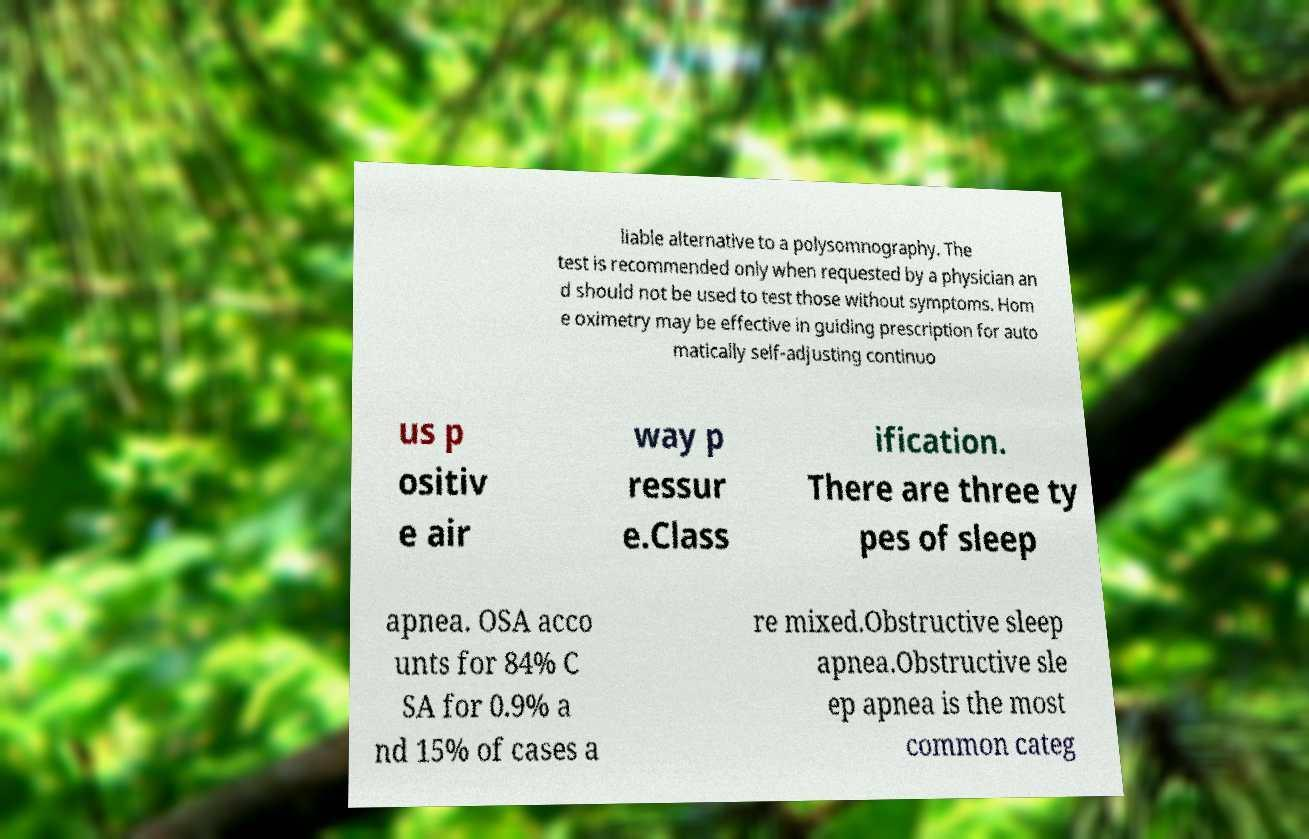For documentation purposes, I need the text within this image transcribed. Could you provide that? liable alternative to a polysomnography. The test is recommended only when requested by a physician an d should not be used to test those without symptoms. Hom e oximetry may be effective in guiding prescription for auto matically self-adjusting continuo us p ositiv e air way p ressur e.Class ification. There are three ty pes of sleep apnea. OSA acco unts for 84% C SA for 0.9% a nd 15% of cases a re mixed.Obstructive sleep apnea.Obstructive sle ep apnea is the most common categ 